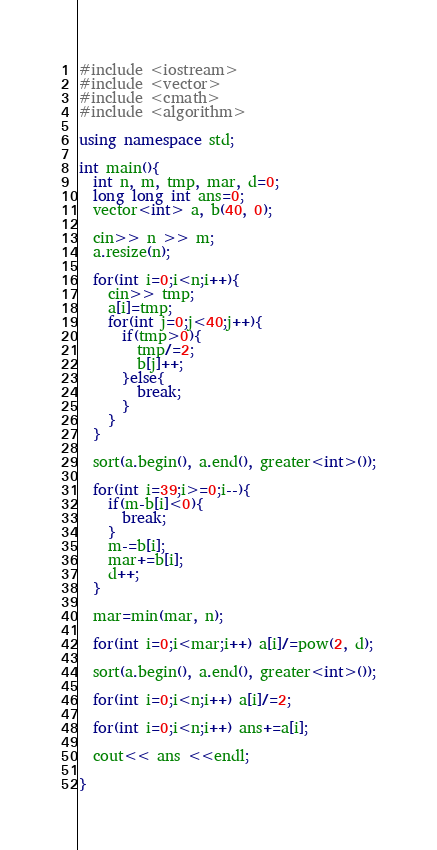Convert code to text. <code><loc_0><loc_0><loc_500><loc_500><_C++_>#include <iostream>
#include <vector>
#include <cmath>
#include <algorithm>

using namespace std;

int main(){
  int n, m, tmp, mar, d=0;
  long long int ans=0;
  vector<int> a, b(40, 0);
  
  cin>> n >> m;
  a.resize(n);
  
  for(int i=0;i<n;i++){
    cin>> tmp;
    a[i]=tmp;
    for(int j=0;j<40;j++){
      if(tmp>0){
        tmp/=2;
        b[j]++;
      }else{
        break;
      }
    }
  }

  sort(a.begin(), a.end(), greater<int>());

  for(int i=39;i>=0;i--){
    if(m-b[i]<0){
      break;
    }
    m-=b[i];
    mar+=b[i];
    d++;
  }

  mar=min(mar, n);

  for(int i=0;i<mar;i++) a[i]/=pow(2, d);
  
  sort(a.begin(), a.end(), greater<int>());
  
  for(int i=0;i<n;i++) a[i]/=2;
  
  for(int i=0;i<n;i++) ans+=a[i];
  
  cout<< ans <<endl;
  
}
</code> 